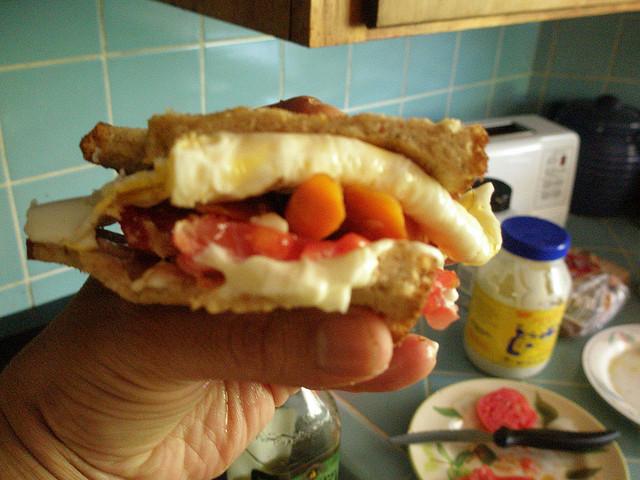What is in the jar?
Quick response, please. Mayo. Is that a carrot in that sandwich?
Give a very brief answer. Yes. What color is the backsplash?
Quick response, please. Blue. 